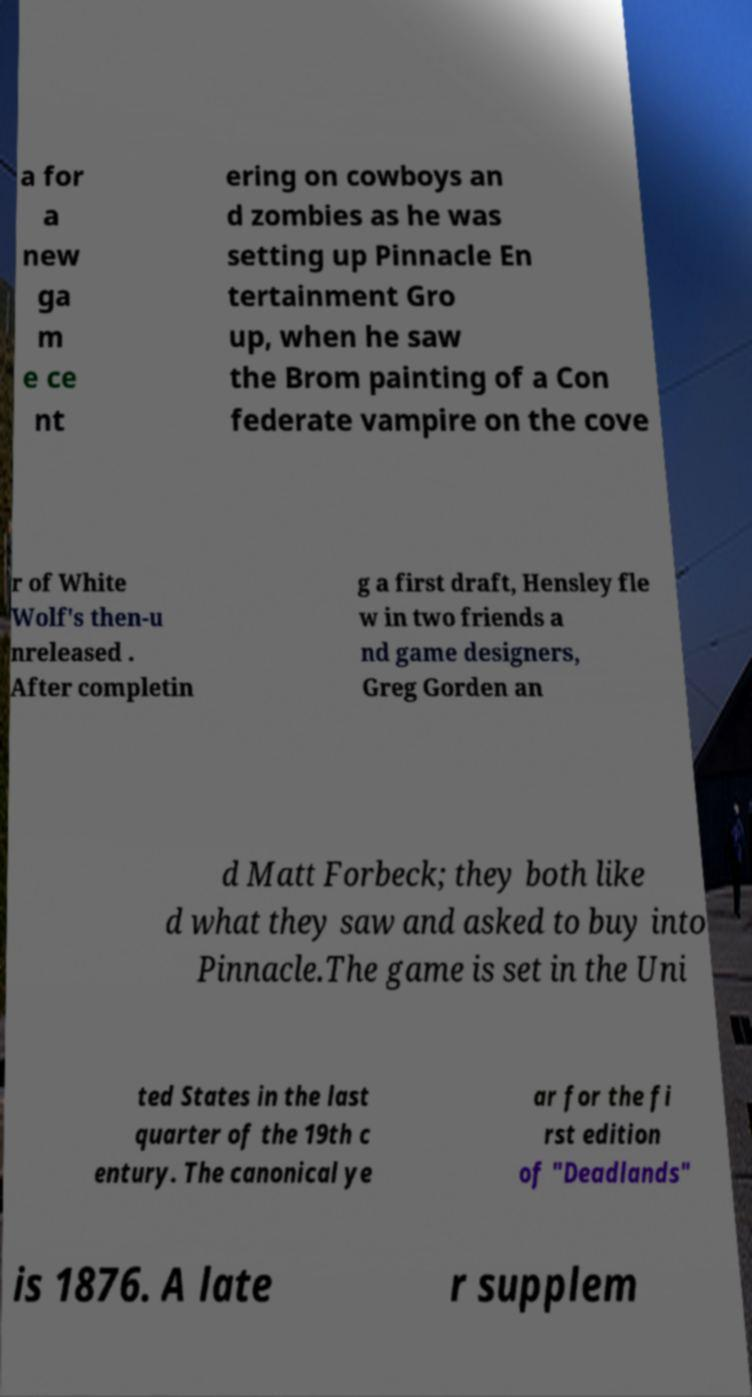There's text embedded in this image that I need extracted. Can you transcribe it verbatim? a for a new ga m e ce nt ering on cowboys an d zombies as he was setting up Pinnacle En tertainment Gro up, when he saw the Brom painting of a Con federate vampire on the cove r of White Wolf's then-u nreleased . After completin g a first draft, Hensley fle w in two friends a nd game designers, Greg Gorden an d Matt Forbeck; they both like d what they saw and asked to buy into Pinnacle.The game is set in the Uni ted States in the last quarter of the 19th c entury. The canonical ye ar for the fi rst edition of "Deadlands" is 1876. A late r supplem 